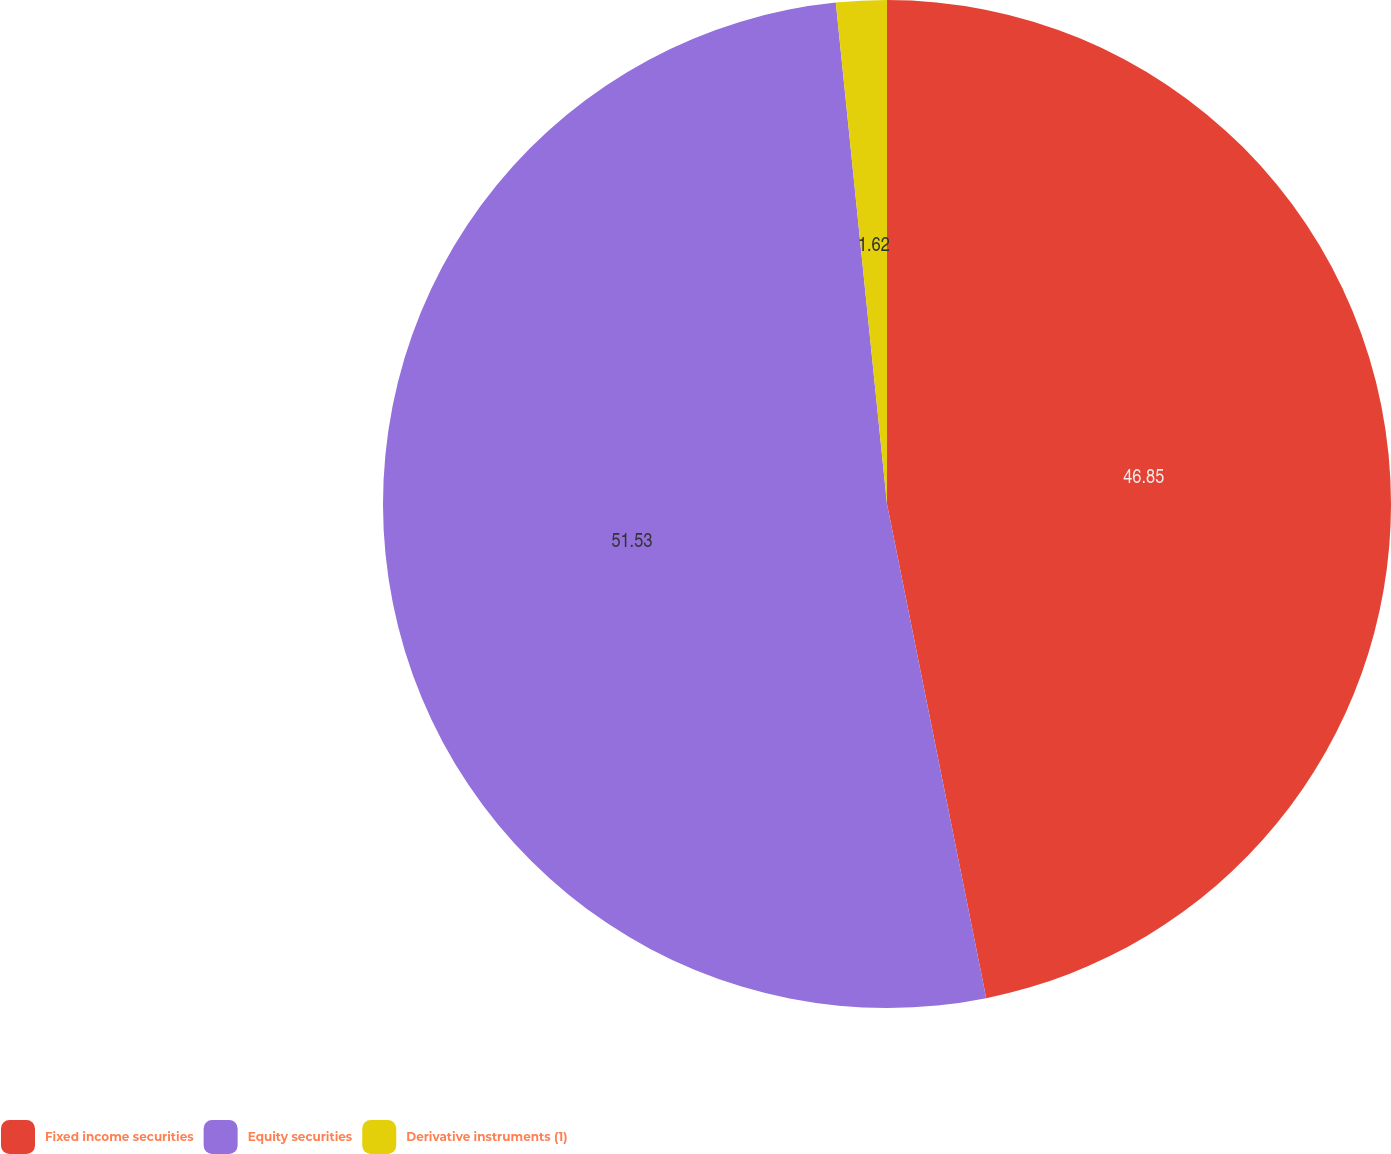<chart> <loc_0><loc_0><loc_500><loc_500><pie_chart><fcel>Fixed income securities<fcel>Equity securities<fcel>Derivative instruments (1)<nl><fcel>46.85%<fcel>51.54%<fcel>1.62%<nl></chart> 